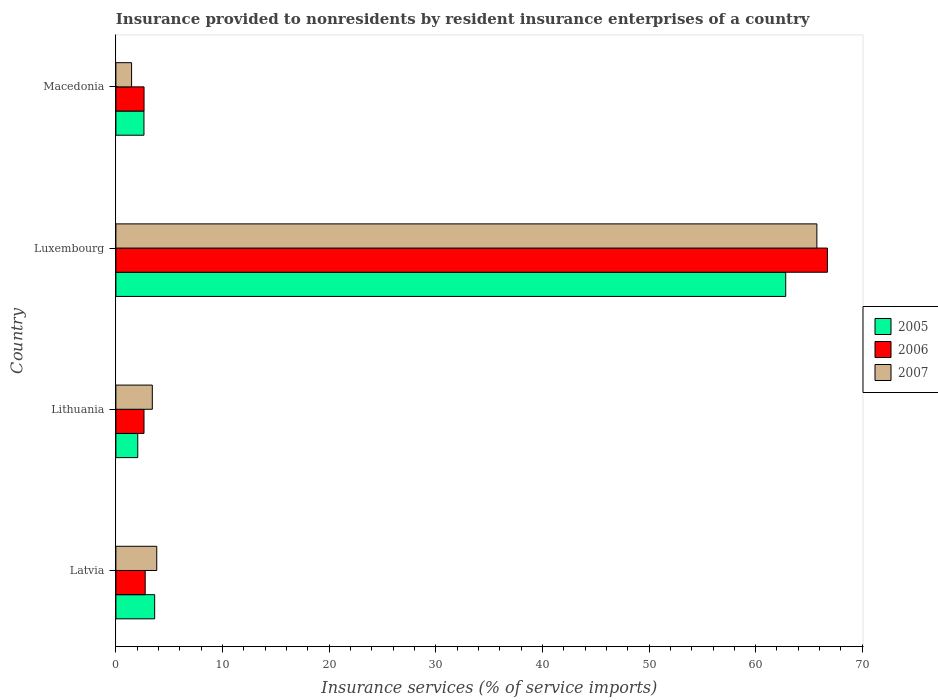How many different coloured bars are there?
Your response must be concise. 3. Are the number of bars per tick equal to the number of legend labels?
Ensure brevity in your answer.  Yes. Are the number of bars on each tick of the Y-axis equal?
Offer a very short reply. Yes. What is the label of the 3rd group of bars from the top?
Your answer should be compact. Lithuania. In how many cases, is the number of bars for a given country not equal to the number of legend labels?
Your response must be concise. 0. What is the insurance provided to nonresidents in 2005 in Macedonia?
Ensure brevity in your answer.  2.63. Across all countries, what is the maximum insurance provided to nonresidents in 2005?
Offer a terse response. 62.82. Across all countries, what is the minimum insurance provided to nonresidents in 2005?
Your answer should be very brief. 2.05. In which country was the insurance provided to nonresidents in 2006 maximum?
Your answer should be compact. Luxembourg. In which country was the insurance provided to nonresidents in 2007 minimum?
Give a very brief answer. Macedonia. What is the total insurance provided to nonresidents in 2005 in the graph?
Give a very brief answer. 71.14. What is the difference between the insurance provided to nonresidents in 2006 in Lithuania and that in Macedonia?
Make the answer very short. -0. What is the difference between the insurance provided to nonresidents in 2006 in Luxembourg and the insurance provided to nonresidents in 2007 in Macedonia?
Provide a short and direct response. 65.26. What is the average insurance provided to nonresidents in 2006 per country?
Make the answer very short. 18.69. What is the difference between the insurance provided to nonresidents in 2006 and insurance provided to nonresidents in 2005 in Latvia?
Give a very brief answer. -0.89. What is the ratio of the insurance provided to nonresidents in 2007 in Luxembourg to that in Macedonia?
Provide a succinct answer. 44.64. Is the difference between the insurance provided to nonresidents in 2006 in Latvia and Macedonia greater than the difference between the insurance provided to nonresidents in 2005 in Latvia and Macedonia?
Make the answer very short. No. What is the difference between the highest and the second highest insurance provided to nonresidents in 2005?
Make the answer very short. 59.18. What is the difference between the highest and the lowest insurance provided to nonresidents in 2006?
Provide a succinct answer. 64.09. What does the 2nd bar from the top in Luxembourg represents?
Your answer should be compact. 2006. Are all the bars in the graph horizontal?
Provide a short and direct response. Yes. What is the difference between two consecutive major ticks on the X-axis?
Give a very brief answer. 10. Are the values on the major ticks of X-axis written in scientific E-notation?
Your response must be concise. No. Does the graph contain any zero values?
Your answer should be compact. No. Where does the legend appear in the graph?
Your answer should be compact. Center right. How many legend labels are there?
Your answer should be very brief. 3. What is the title of the graph?
Your answer should be very brief. Insurance provided to nonresidents by resident insurance enterprises of a country. Does "1980" appear as one of the legend labels in the graph?
Provide a succinct answer. No. What is the label or title of the X-axis?
Your answer should be compact. Insurance services (% of service imports). What is the label or title of the Y-axis?
Your answer should be very brief. Country. What is the Insurance services (% of service imports) in 2005 in Latvia?
Provide a short and direct response. 3.64. What is the Insurance services (% of service imports) of 2006 in Latvia?
Your answer should be very brief. 2.75. What is the Insurance services (% of service imports) of 2007 in Latvia?
Your answer should be compact. 3.83. What is the Insurance services (% of service imports) in 2005 in Lithuania?
Ensure brevity in your answer.  2.05. What is the Insurance services (% of service imports) of 2006 in Lithuania?
Your response must be concise. 2.64. What is the Insurance services (% of service imports) in 2007 in Lithuania?
Keep it short and to the point. 3.42. What is the Insurance services (% of service imports) in 2005 in Luxembourg?
Make the answer very short. 62.82. What is the Insurance services (% of service imports) in 2006 in Luxembourg?
Ensure brevity in your answer.  66.73. What is the Insurance services (% of service imports) of 2007 in Luxembourg?
Provide a short and direct response. 65.74. What is the Insurance services (% of service imports) in 2005 in Macedonia?
Give a very brief answer. 2.63. What is the Insurance services (% of service imports) of 2006 in Macedonia?
Your response must be concise. 2.64. What is the Insurance services (% of service imports) in 2007 in Macedonia?
Give a very brief answer. 1.47. Across all countries, what is the maximum Insurance services (% of service imports) in 2005?
Keep it short and to the point. 62.82. Across all countries, what is the maximum Insurance services (% of service imports) in 2006?
Make the answer very short. 66.73. Across all countries, what is the maximum Insurance services (% of service imports) of 2007?
Provide a short and direct response. 65.74. Across all countries, what is the minimum Insurance services (% of service imports) of 2005?
Your response must be concise. 2.05. Across all countries, what is the minimum Insurance services (% of service imports) in 2006?
Your answer should be very brief. 2.64. Across all countries, what is the minimum Insurance services (% of service imports) in 2007?
Keep it short and to the point. 1.47. What is the total Insurance services (% of service imports) in 2005 in the graph?
Make the answer very short. 71.14. What is the total Insurance services (% of service imports) of 2006 in the graph?
Offer a terse response. 74.75. What is the total Insurance services (% of service imports) in 2007 in the graph?
Keep it short and to the point. 74.46. What is the difference between the Insurance services (% of service imports) of 2005 in Latvia and that in Lithuania?
Give a very brief answer. 1.59. What is the difference between the Insurance services (% of service imports) in 2006 in Latvia and that in Lithuania?
Your answer should be compact. 0.11. What is the difference between the Insurance services (% of service imports) in 2007 in Latvia and that in Lithuania?
Make the answer very short. 0.42. What is the difference between the Insurance services (% of service imports) in 2005 in Latvia and that in Luxembourg?
Your response must be concise. -59.18. What is the difference between the Insurance services (% of service imports) of 2006 in Latvia and that in Luxembourg?
Provide a succinct answer. -63.98. What is the difference between the Insurance services (% of service imports) of 2007 in Latvia and that in Luxembourg?
Give a very brief answer. -61.91. What is the difference between the Insurance services (% of service imports) in 2006 in Latvia and that in Macedonia?
Your answer should be very brief. 0.11. What is the difference between the Insurance services (% of service imports) in 2007 in Latvia and that in Macedonia?
Provide a short and direct response. 2.36. What is the difference between the Insurance services (% of service imports) of 2005 in Lithuania and that in Luxembourg?
Offer a terse response. -60.77. What is the difference between the Insurance services (% of service imports) of 2006 in Lithuania and that in Luxembourg?
Your answer should be compact. -64.09. What is the difference between the Insurance services (% of service imports) of 2007 in Lithuania and that in Luxembourg?
Your answer should be compact. -62.33. What is the difference between the Insurance services (% of service imports) of 2005 in Lithuania and that in Macedonia?
Keep it short and to the point. -0.58. What is the difference between the Insurance services (% of service imports) in 2006 in Lithuania and that in Macedonia?
Your response must be concise. -0. What is the difference between the Insurance services (% of service imports) of 2007 in Lithuania and that in Macedonia?
Make the answer very short. 1.94. What is the difference between the Insurance services (% of service imports) in 2005 in Luxembourg and that in Macedonia?
Keep it short and to the point. 60.19. What is the difference between the Insurance services (% of service imports) in 2006 in Luxembourg and that in Macedonia?
Provide a succinct answer. 64.09. What is the difference between the Insurance services (% of service imports) in 2007 in Luxembourg and that in Macedonia?
Provide a short and direct response. 64.27. What is the difference between the Insurance services (% of service imports) of 2005 in Latvia and the Insurance services (% of service imports) of 2007 in Lithuania?
Offer a terse response. 0.22. What is the difference between the Insurance services (% of service imports) of 2005 in Latvia and the Insurance services (% of service imports) of 2006 in Luxembourg?
Keep it short and to the point. -63.09. What is the difference between the Insurance services (% of service imports) of 2005 in Latvia and the Insurance services (% of service imports) of 2007 in Luxembourg?
Offer a terse response. -62.1. What is the difference between the Insurance services (% of service imports) of 2006 in Latvia and the Insurance services (% of service imports) of 2007 in Luxembourg?
Offer a terse response. -62.99. What is the difference between the Insurance services (% of service imports) in 2005 in Latvia and the Insurance services (% of service imports) in 2007 in Macedonia?
Give a very brief answer. 2.16. What is the difference between the Insurance services (% of service imports) of 2006 in Latvia and the Insurance services (% of service imports) of 2007 in Macedonia?
Offer a very short reply. 1.28. What is the difference between the Insurance services (% of service imports) of 2005 in Lithuania and the Insurance services (% of service imports) of 2006 in Luxembourg?
Provide a succinct answer. -64.68. What is the difference between the Insurance services (% of service imports) of 2005 in Lithuania and the Insurance services (% of service imports) of 2007 in Luxembourg?
Provide a short and direct response. -63.69. What is the difference between the Insurance services (% of service imports) in 2006 in Lithuania and the Insurance services (% of service imports) in 2007 in Luxembourg?
Give a very brief answer. -63.1. What is the difference between the Insurance services (% of service imports) in 2005 in Lithuania and the Insurance services (% of service imports) in 2006 in Macedonia?
Keep it short and to the point. -0.59. What is the difference between the Insurance services (% of service imports) of 2005 in Lithuania and the Insurance services (% of service imports) of 2007 in Macedonia?
Your answer should be very brief. 0.58. What is the difference between the Insurance services (% of service imports) in 2006 in Lithuania and the Insurance services (% of service imports) in 2007 in Macedonia?
Your answer should be very brief. 1.16. What is the difference between the Insurance services (% of service imports) of 2005 in Luxembourg and the Insurance services (% of service imports) of 2006 in Macedonia?
Your answer should be compact. 60.18. What is the difference between the Insurance services (% of service imports) of 2005 in Luxembourg and the Insurance services (% of service imports) of 2007 in Macedonia?
Provide a succinct answer. 61.35. What is the difference between the Insurance services (% of service imports) of 2006 in Luxembourg and the Insurance services (% of service imports) of 2007 in Macedonia?
Ensure brevity in your answer.  65.26. What is the average Insurance services (% of service imports) of 2005 per country?
Give a very brief answer. 17.78. What is the average Insurance services (% of service imports) in 2006 per country?
Keep it short and to the point. 18.69. What is the average Insurance services (% of service imports) in 2007 per country?
Provide a succinct answer. 18.62. What is the difference between the Insurance services (% of service imports) of 2005 and Insurance services (% of service imports) of 2006 in Latvia?
Offer a very short reply. 0.89. What is the difference between the Insurance services (% of service imports) in 2005 and Insurance services (% of service imports) in 2007 in Latvia?
Ensure brevity in your answer.  -0.2. What is the difference between the Insurance services (% of service imports) of 2006 and Insurance services (% of service imports) of 2007 in Latvia?
Give a very brief answer. -1.08. What is the difference between the Insurance services (% of service imports) in 2005 and Insurance services (% of service imports) in 2006 in Lithuania?
Keep it short and to the point. -0.59. What is the difference between the Insurance services (% of service imports) of 2005 and Insurance services (% of service imports) of 2007 in Lithuania?
Give a very brief answer. -1.37. What is the difference between the Insurance services (% of service imports) in 2006 and Insurance services (% of service imports) in 2007 in Lithuania?
Your answer should be compact. -0.78. What is the difference between the Insurance services (% of service imports) of 2005 and Insurance services (% of service imports) of 2006 in Luxembourg?
Your answer should be very brief. -3.91. What is the difference between the Insurance services (% of service imports) in 2005 and Insurance services (% of service imports) in 2007 in Luxembourg?
Give a very brief answer. -2.92. What is the difference between the Insurance services (% of service imports) of 2005 and Insurance services (% of service imports) of 2006 in Macedonia?
Your response must be concise. -0.01. What is the difference between the Insurance services (% of service imports) in 2005 and Insurance services (% of service imports) in 2007 in Macedonia?
Provide a short and direct response. 1.16. What is the difference between the Insurance services (% of service imports) in 2006 and Insurance services (% of service imports) in 2007 in Macedonia?
Ensure brevity in your answer.  1.17. What is the ratio of the Insurance services (% of service imports) in 2005 in Latvia to that in Lithuania?
Your response must be concise. 1.77. What is the ratio of the Insurance services (% of service imports) of 2006 in Latvia to that in Lithuania?
Offer a very short reply. 1.04. What is the ratio of the Insurance services (% of service imports) in 2007 in Latvia to that in Lithuania?
Provide a short and direct response. 1.12. What is the ratio of the Insurance services (% of service imports) in 2005 in Latvia to that in Luxembourg?
Your answer should be compact. 0.06. What is the ratio of the Insurance services (% of service imports) in 2006 in Latvia to that in Luxembourg?
Keep it short and to the point. 0.04. What is the ratio of the Insurance services (% of service imports) in 2007 in Latvia to that in Luxembourg?
Provide a succinct answer. 0.06. What is the ratio of the Insurance services (% of service imports) in 2005 in Latvia to that in Macedonia?
Offer a very short reply. 1.38. What is the ratio of the Insurance services (% of service imports) of 2006 in Latvia to that in Macedonia?
Give a very brief answer. 1.04. What is the ratio of the Insurance services (% of service imports) of 2007 in Latvia to that in Macedonia?
Provide a succinct answer. 2.6. What is the ratio of the Insurance services (% of service imports) of 2005 in Lithuania to that in Luxembourg?
Offer a terse response. 0.03. What is the ratio of the Insurance services (% of service imports) in 2006 in Lithuania to that in Luxembourg?
Provide a succinct answer. 0.04. What is the ratio of the Insurance services (% of service imports) of 2007 in Lithuania to that in Luxembourg?
Provide a succinct answer. 0.05. What is the ratio of the Insurance services (% of service imports) in 2005 in Lithuania to that in Macedonia?
Ensure brevity in your answer.  0.78. What is the ratio of the Insurance services (% of service imports) of 2006 in Lithuania to that in Macedonia?
Your answer should be compact. 1. What is the ratio of the Insurance services (% of service imports) of 2007 in Lithuania to that in Macedonia?
Give a very brief answer. 2.32. What is the ratio of the Insurance services (% of service imports) of 2005 in Luxembourg to that in Macedonia?
Provide a succinct answer. 23.87. What is the ratio of the Insurance services (% of service imports) in 2006 in Luxembourg to that in Macedonia?
Give a very brief answer. 25.28. What is the ratio of the Insurance services (% of service imports) of 2007 in Luxembourg to that in Macedonia?
Provide a succinct answer. 44.64. What is the difference between the highest and the second highest Insurance services (% of service imports) of 2005?
Your answer should be very brief. 59.18. What is the difference between the highest and the second highest Insurance services (% of service imports) in 2006?
Make the answer very short. 63.98. What is the difference between the highest and the second highest Insurance services (% of service imports) in 2007?
Your answer should be very brief. 61.91. What is the difference between the highest and the lowest Insurance services (% of service imports) of 2005?
Make the answer very short. 60.77. What is the difference between the highest and the lowest Insurance services (% of service imports) of 2006?
Your answer should be compact. 64.09. What is the difference between the highest and the lowest Insurance services (% of service imports) of 2007?
Give a very brief answer. 64.27. 